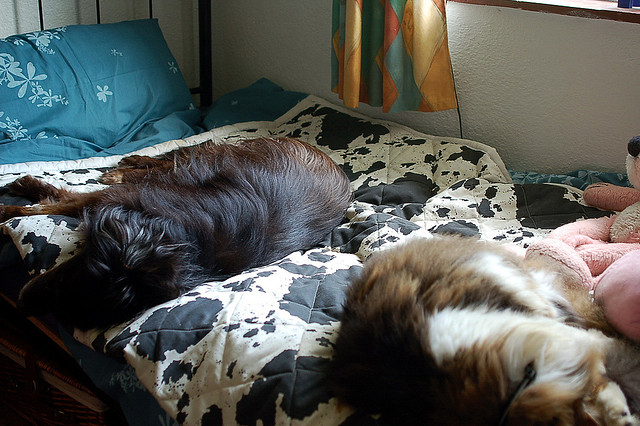How many dogs are in the photo? 2 